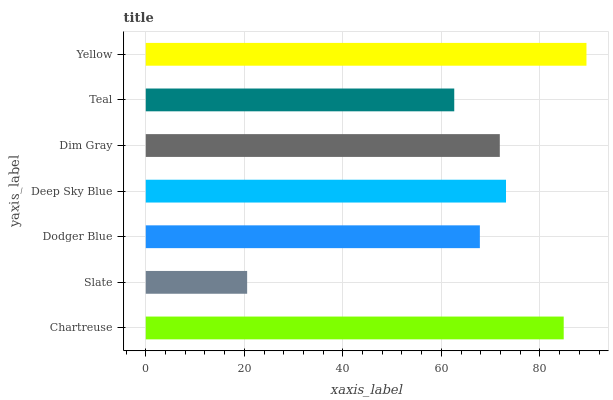Is Slate the minimum?
Answer yes or no. Yes. Is Yellow the maximum?
Answer yes or no. Yes. Is Dodger Blue the minimum?
Answer yes or no. No. Is Dodger Blue the maximum?
Answer yes or no. No. Is Dodger Blue greater than Slate?
Answer yes or no. Yes. Is Slate less than Dodger Blue?
Answer yes or no. Yes. Is Slate greater than Dodger Blue?
Answer yes or no. No. Is Dodger Blue less than Slate?
Answer yes or no. No. Is Dim Gray the high median?
Answer yes or no. Yes. Is Dim Gray the low median?
Answer yes or no. Yes. Is Slate the high median?
Answer yes or no. No. Is Slate the low median?
Answer yes or no. No. 